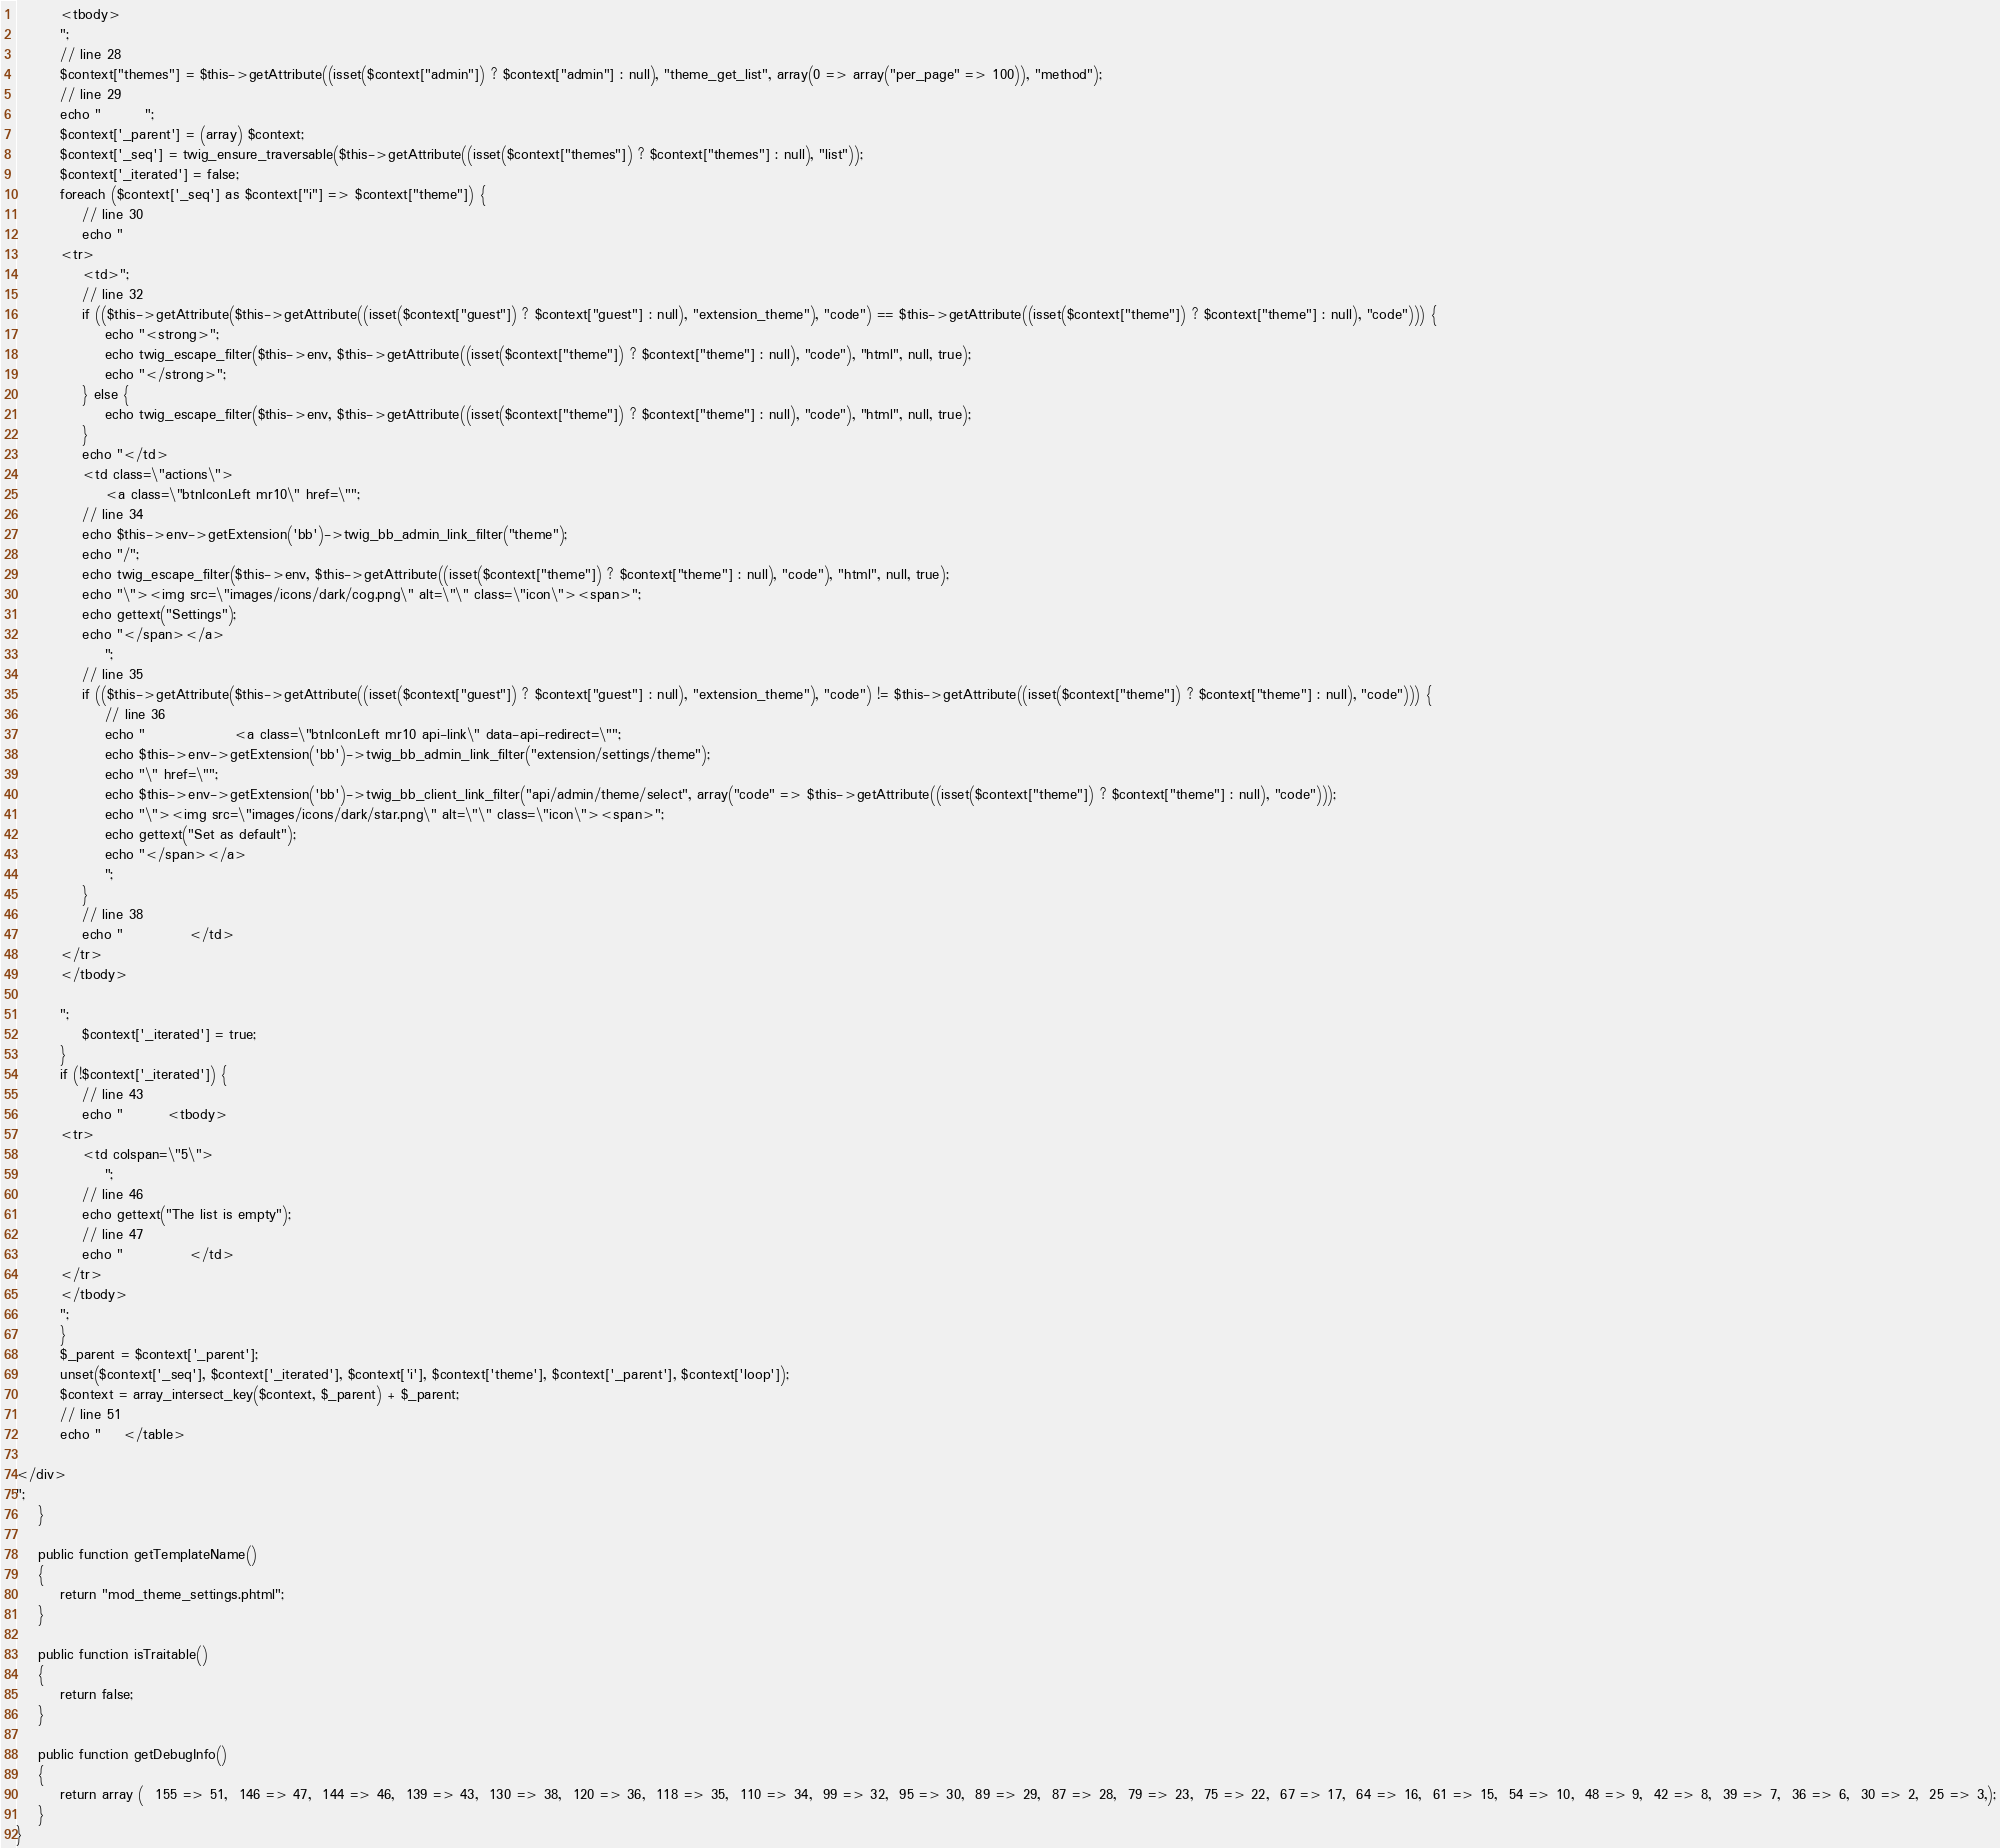Convert code to text. <code><loc_0><loc_0><loc_500><loc_500><_PHP_>
        <tbody>
        ";
        // line 28
        $context["themes"] = $this->getAttribute((isset($context["admin"]) ? $context["admin"] : null), "theme_get_list", array(0 => array("per_page" => 100)), "method");
        // line 29
        echo "        ";
        $context['_parent'] = (array) $context;
        $context['_seq'] = twig_ensure_traversable($this->getAttribute((isset($context["themes"]) ? $context["themes"] : null), "list"));
        $context['_iterated'] = false;
        foreach ($context['_seq'] as $context["i"] => $context["theme"]) {
            // line 30
            echo "
        <tr>
            <td>";
            // line 32
            if (($this->getAttribute($this->getAttribute((isset($context["guest"]) ? $context["guest"] : null), "extension_theme"), "code") == $this->getAttribute((isset($context["theme"]) ? $context["theme"] : null), "code"))) {
                echo "<strong>";
                echo twig_escape_filter($this->env, $this->getAttribute((isset($context["theme"]) ? $context["theme"] : null), "code"), "html", null, true);
                echo "</strong>";
            } else {
                echo twig_escape_filter($this->env, $this->getAttribute((isset($context["theme"]) ? $context["theme"] : null), "code"), "html", null, true);
            }
            echo "</td>
            <td class=\"actions\">
                <a class=\"btnIconLeft mr10\" href=\"";
            // line 34
            echo $this->env->getExtension('bb')->twig_bb_admin_link_filter("theme");
            echo "/";
            echo twig_escape_filter($this->env, $this->getAttribute((isset($context["theme"]) ? $context["theme"] : null), "code"), "html", null, true);
            echo "\"><img src=\"images/icons/dark/cog.png\" alt=\"\" class=\"icon\"><span>";
            echo gettext("Settings");
            echo "</span></a>
                ";
            // line 35
            if (($this->getAttribute($this->getAttribute((isset($context["guest"]) ? $context["guest"] : null), "extension_theme"), "code") != $this->getAttribute((isset($context["theme"]) ? $context["theme"] : null), "code"))) {
                // line 36
                echo "                <a class=\"btnIconLeft mr10 api-link\" data-api-redirect=\"";
                echo $this->env->getExtension('bb')->twig_bb_admin_link_filter("extension/settings/theme");
                echo "\" href=\"";
                echo $this->env->getExtension('bb')->twig_bb_client_link_filter("api/admin/theme/select", array("code" => $this->getAttribute((isset($context["theme"]) ? $context["theme"] : null), "code")));
                echo "\"><img src=\"images/icons/dark/star.png\" alt=\"\" class=\"icon\"><span>";
                echo gettext("Set as default");
                echo "</span></a>
                ";
            }
            // line 38
            echo "            </td>
        </tr>
        </tbody>

        ";
            $context['_iterated'] = true;
        }
        if (!$context['_iterated']) {
            // line 43
            echo "        <tbody>
        <tr>
            <td colspan=\"5\">
                ";
            // line 46
            echo gettext("The list is empty");
            // line 47
            echo "            </td>
        </tr>
        </tbody>
        ";
        }
        $_parent = $context['_parent'];
        unset($context['_seq'], $context['_iterated'], $context['i'], $context['theme'], $context['_parent'], $context['loop']);
        $context = array_intersect_key($context, $_parent) + $_parent;
        // line 51
        echo "    </table>

</div>
";
    }

    public function getTemplateName()
    {
        return "mod_theme_settings.phtml";
    }

    public function isTraitable()
    {
        return false;
    }

    public function getDebugInfo()
    {
        return array (  155 => 51,  146 => 47,  144 => 46,  139 => 43,  130 => 38,  120 => 36,  118 => 35,  110 => 34,  99 => 32,  95 => 30,  89 => 29,  87 => 28,  79 => 23,  75 => 22,  67 => 17,  64 => 16,  61 => 15,  54 => 10,  48 => 9,  42 => 8,  39 => 7,  36 => 6,  30 => 2,  25 => 3,);
    }
}
</code> 